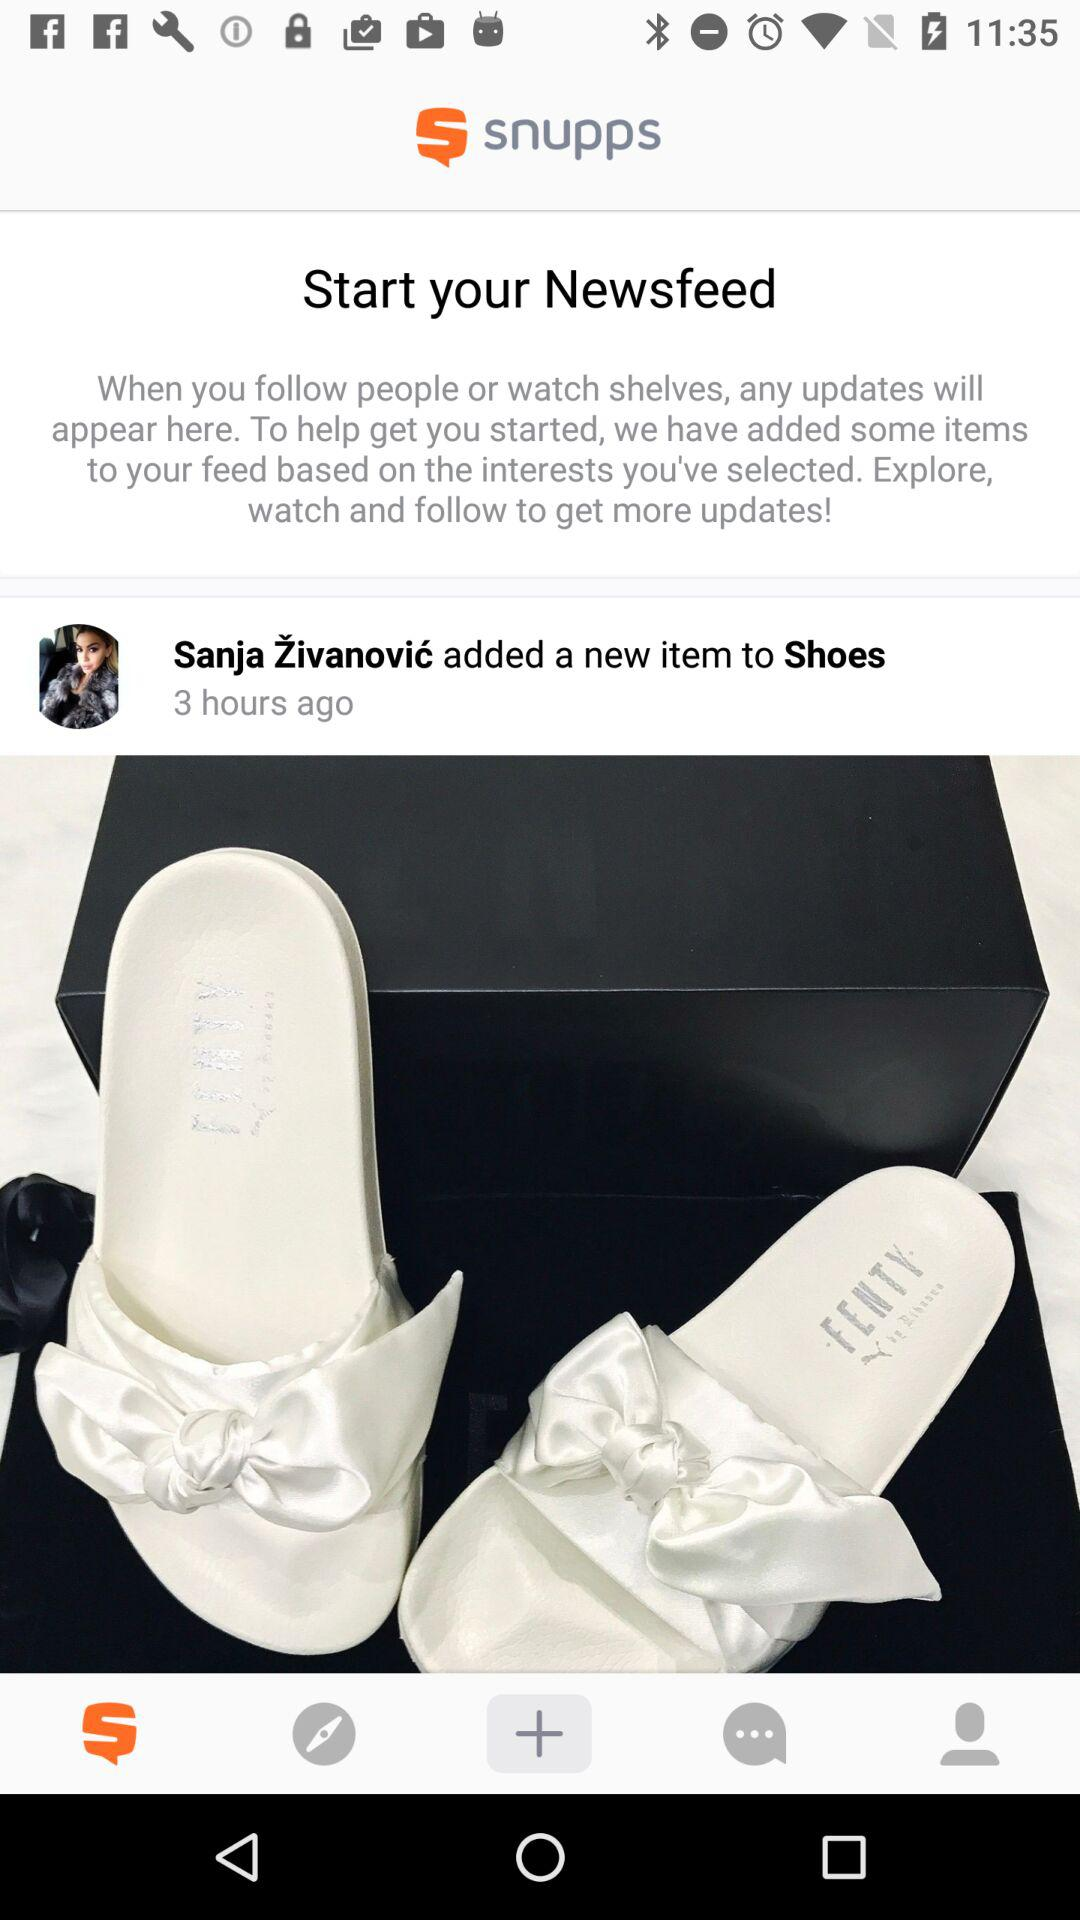How many hours ago did Sanja Živanović add the item?
Answer the question using a single word or phrase. 3 hours ago 